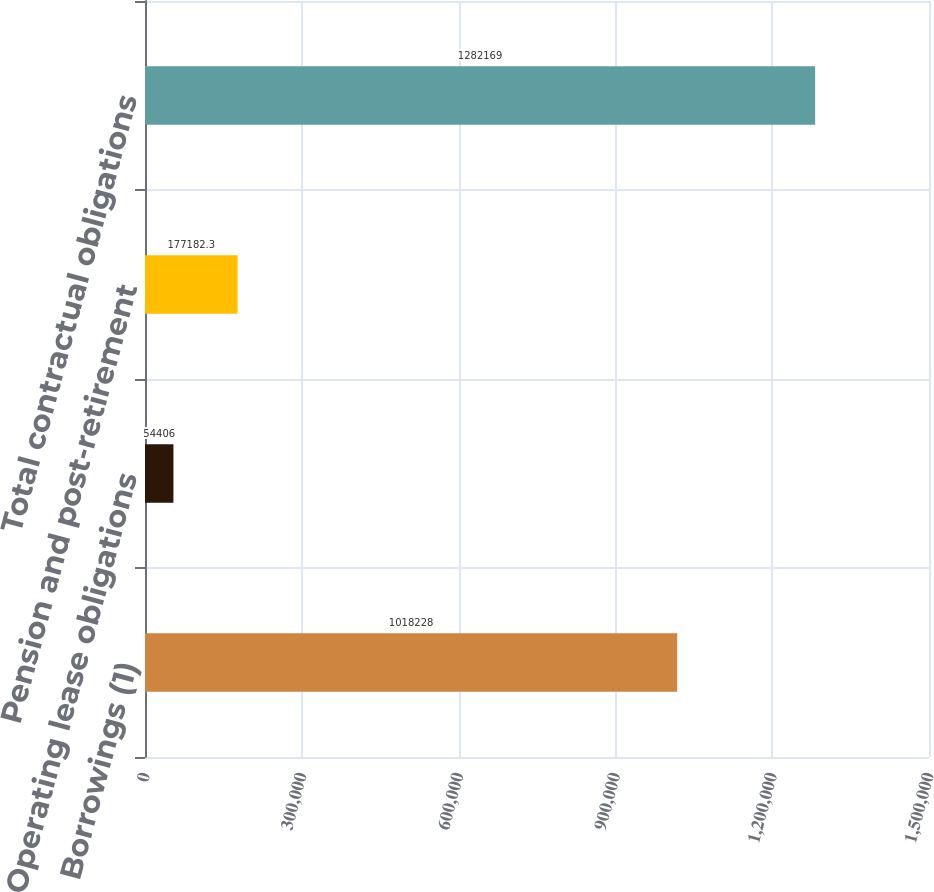Convert chart to OTSL. <chart><loc_0><loc_0><loc_500><loc_500><bar_chart><fcel>Borrowings (1)<fcel>Operating lease obligations<fcel>Pension and post-retirement<fcel>Total contractual obligations<nl><fcel>1.01823e+06<fcel>54406<fcel>177182<fcel>1.28217e+06<nl></chart> 